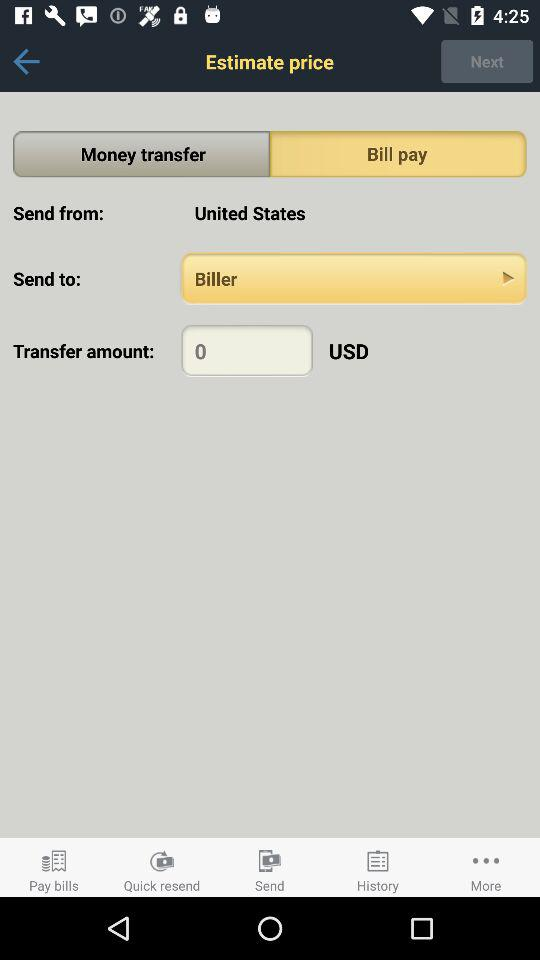To whom is the amount sent? The amount is sent to the Biller. 